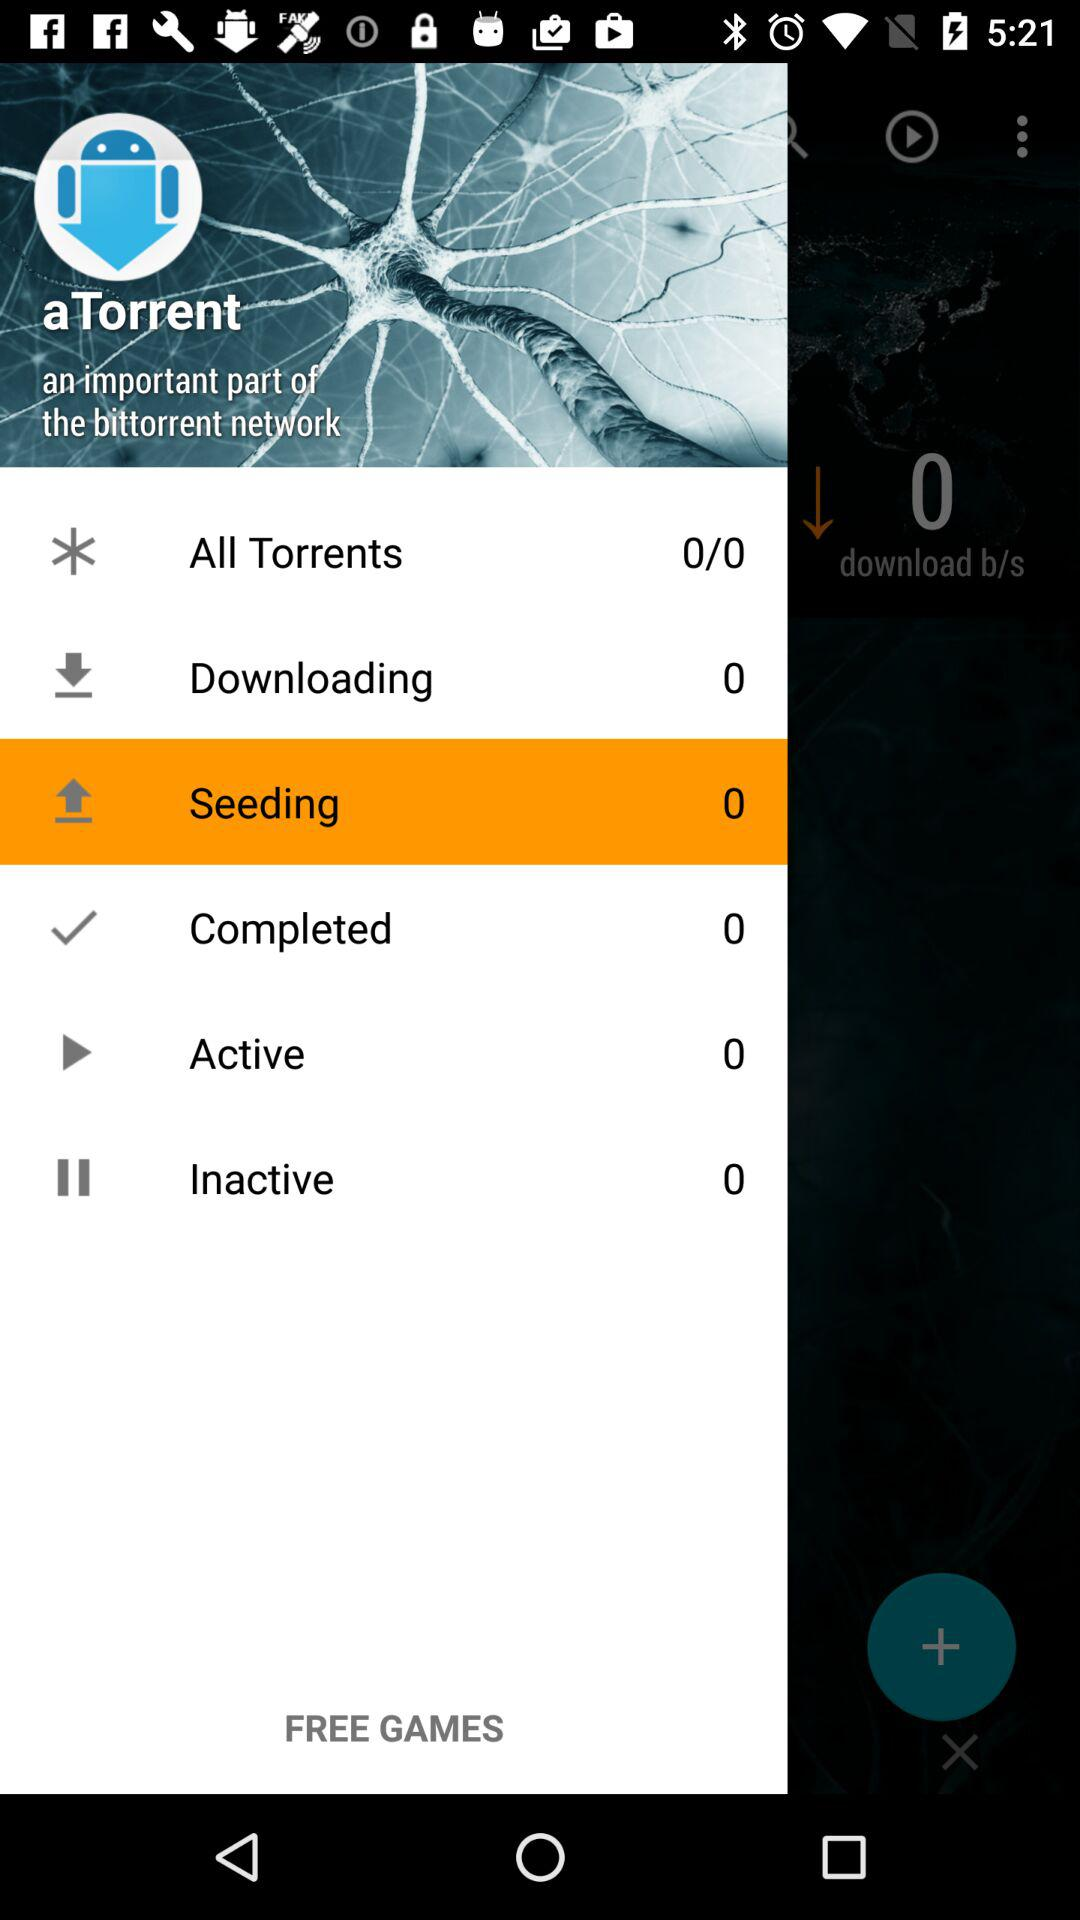What is the number of "Active"? The number of "Active" is 0. 